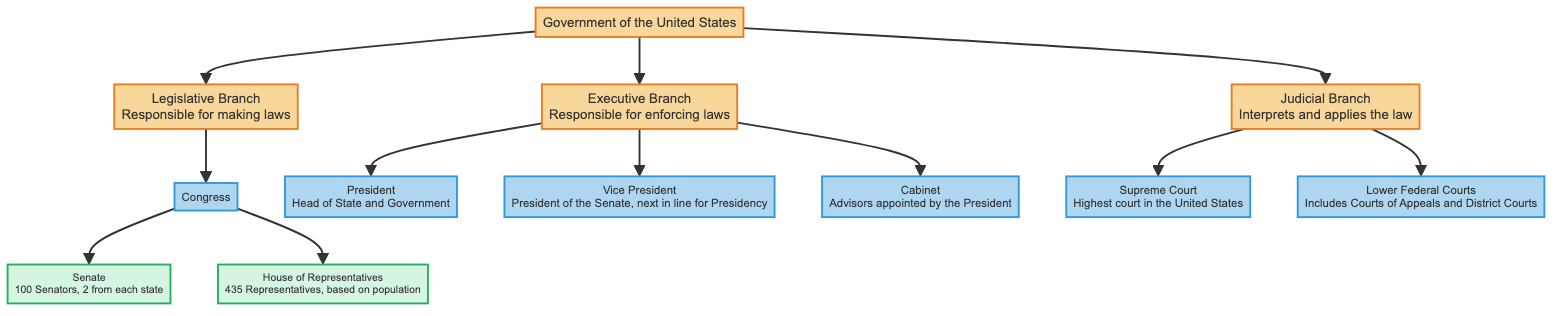What is the main responsibility of the Legislative Branch? The diagram states that the Legislative Branch is responsible for making laws, which is displayed directly beneath the Legislative Branch title.
Answer: Making laws How many Senators are there in the Senate? According to the diagram, the Senate is described as having 100 Senators, which is provided in the subcomponent details.
Answer: 100 What is the role of the Vice President as indicated in the diagram? The diagram outlines that the Vice President is the President of the Senate and besides that, they are next in line for the Presidency, as noted under the Vice President node.
Answer: President of the Senate What are the two components of the Executive Branch? The diagram displays that the Executive Branch has three components: President, Vice President, and Cabinet. It suggests the inquiry focuses on just two, but does not restrict; hence, any two of the three can be answered.
Answer: President, Vice President Which branch of the government interprets and applies the law according to the diagram? The diagram clearly identifies the Judicial Branch as the entity responsible for interpreting and applying the law, which is marked under its title.
Answer: Judicial Branch How many Representatives are in the House of Representatives? The diagram states that there are 435 Representatives in the House, which is explained in the subcomponent details of House of Representatives.
Answer: 435 What is the highest court in the United States as per the diagram? According to the diagram, the Supreme Court is labeled as the highest court in the United States, positioned under the Judicial Branch.
Answer: Supreme Court What components make up the Congress? The diagram details that Congress consists of two components: Senate and House of Representatives, both of which are directly connected to Congress in the diagram.
Answer: Senate, House of Representatives What does the Cabinet consist of? The diagram describes the Cabinet as advisors appointed by the President, which is displayed under the Cabinet node in the Executive Branch.
Answer: Advisors appointed by the President 